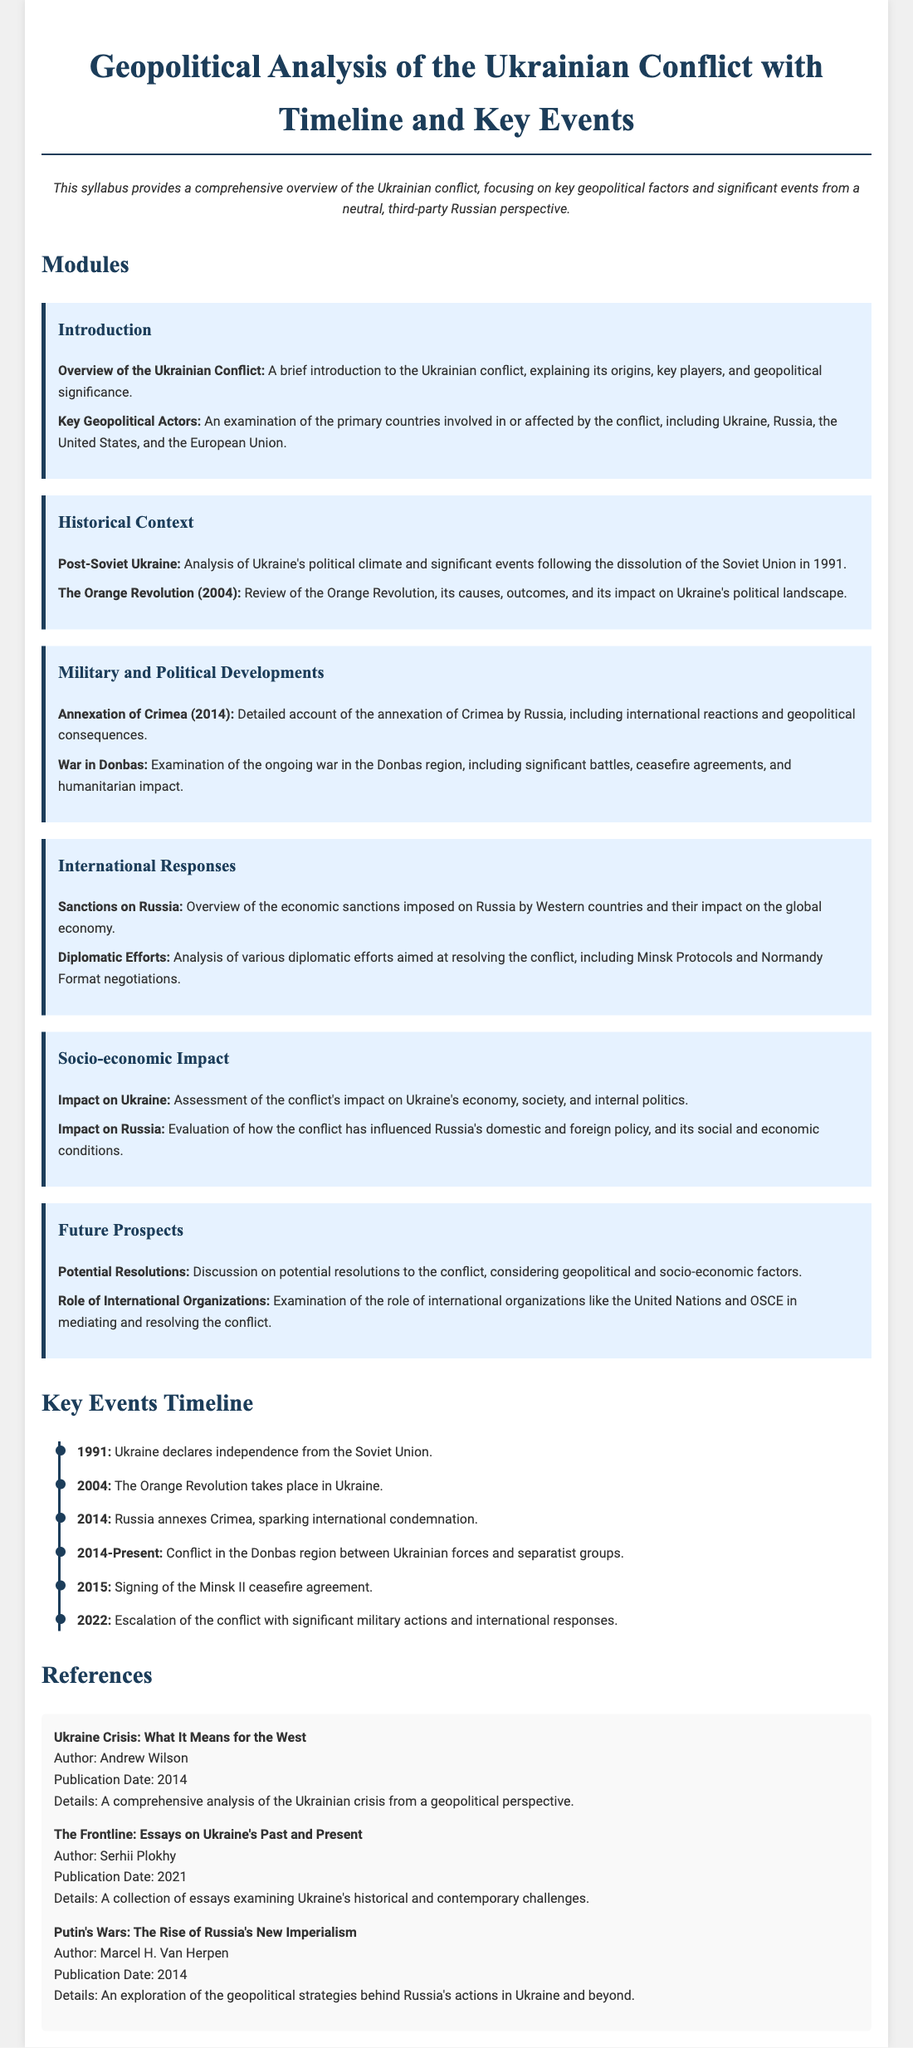what is the title of the syllabus? The title of the syllabus is prominently displayed at the top of the document, providing the main subject of study.
Answer: Geopolitical Analysis of the Ukrainian Conflict with Timeline and Key Events what year did Ukraine declare independence? The timeline section outlines significant events in chronological order, including Ukraine's independence.
Answer: 1991 what major event occurred in 2014? The timeline section includes key events, specifying major occurrences in different years, including a critical event in 2014.
Answer: Russia annexes Crimea what is the focus of the module on Future Prospects? The module discusses potential outcomes and considerations for the future related to the conflict, indicating the themes covered.
Answer: Potential Resolutions who is the author of "Putin's Wars: The Rise of Russia's New Imperialism"? The references section lists publications and their authors, including a key book addressing the topic.
Answer: Marcel H. Van Herpen how many modules are there in the syllabus? By counting the individual sections labeled as modules, one can determine the number of distinct topic areas covered.
Answer: Six what document was signed in 2015? The timeline provides key events that include significant agreements or actions taken during the conflict, helping identify relevant documents.
Answer: Minsk II ceasefire agreement what was the outcome of the Orange Revolution? The module on Historical Context summarizes past events and their impact on politics, allowing for an understanding of this event's results.
Answer: Impact on Ukraine's political landscape what organization is mentioned in the Future Prospects module? The Future Prospects module discusses various entities involved in conflict mediation, highlighting their roles in resolution efforts.
Answer: United Nations 